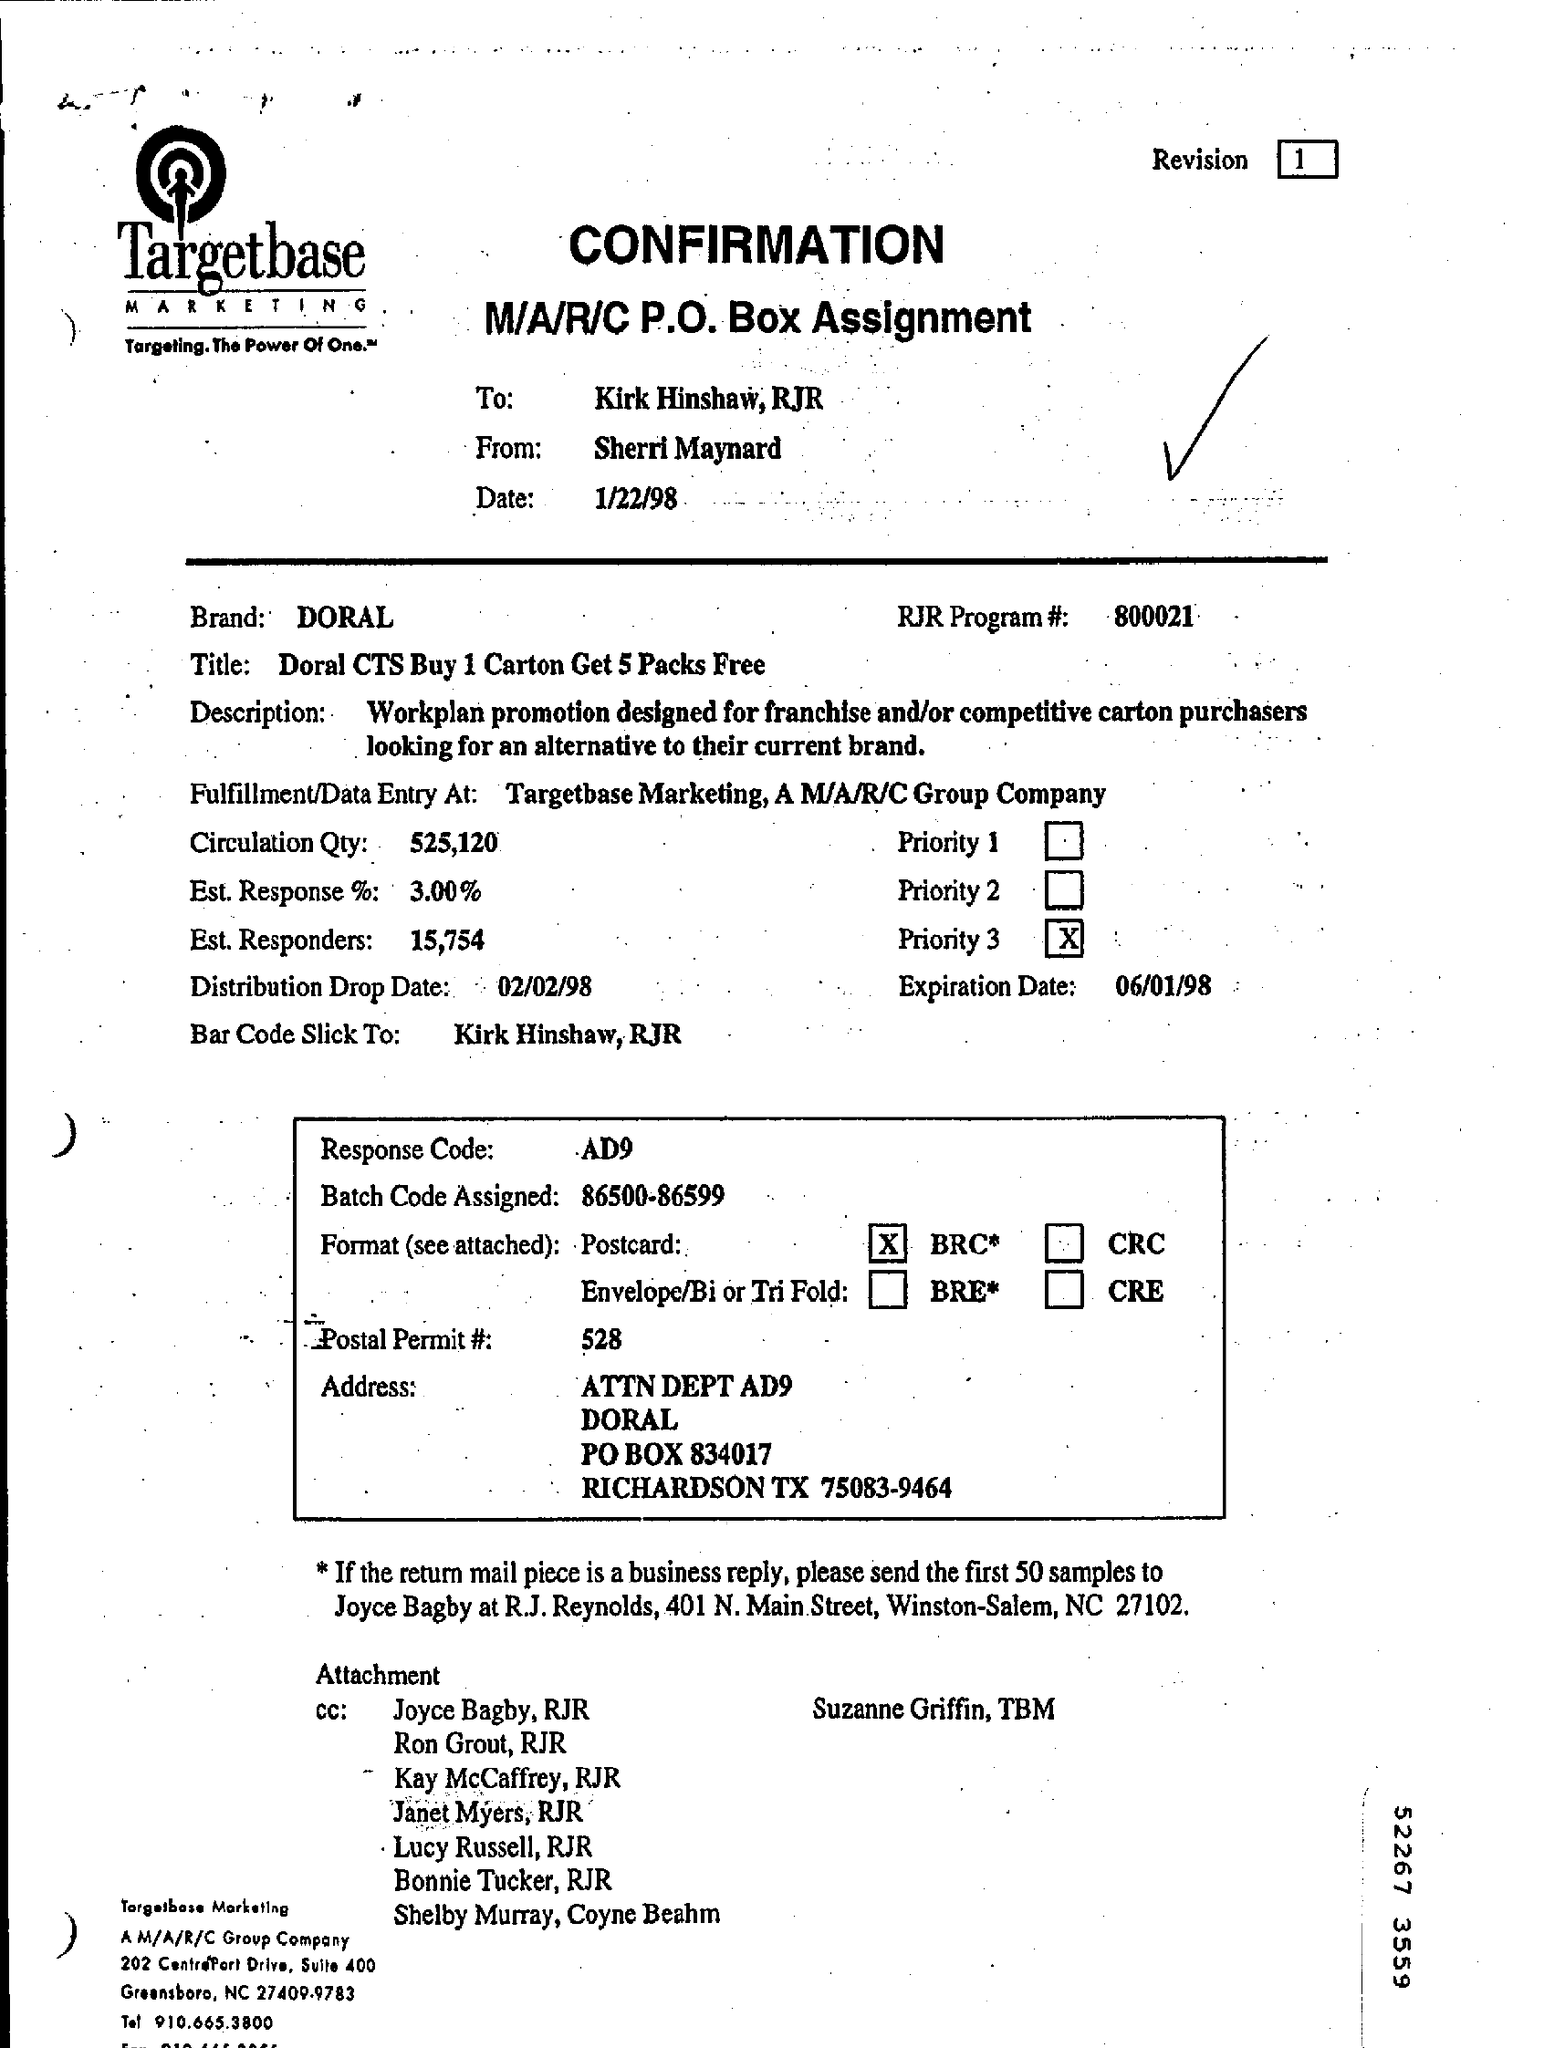Draw attention to some important aspects in this diagram. The brand mentioned is Doral. The RJR Program number is 800021... The confirmation is from Sherri Maynard. The batch code assigned is between 86500 and 86599. The confirmation is addressed to Kirk Hinshaw. 